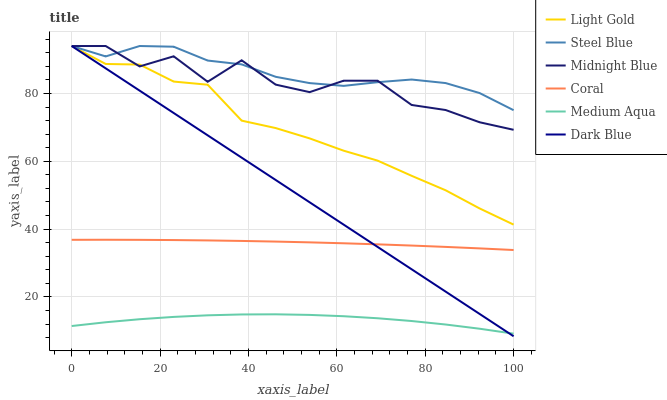Does Medium Aqua have the minimum area under the curve?
Answer yes or no. Yes. Does Steel Blue have the maximum area under the curve?
Answer yes or no. Yes. Does Coral have the minimum area under the curve?
Answer yes or no. No. Does Coral have the maximum area under the curve?
Answer yes or no. No. Is Dark Blue the smoothest?
Answer yes or no. Yes. Is Midnight Blue the roughest?
Answer yes or no. Yes. Is Coral the smoothest?
Answer yes or no. No. Is Coral the roughest?
Answer yes or no. No. Does Dark Blue have the lowest value?
Answer yes or no. Yes. Does Coral have the lowest value?
Answer yes or no. No. Does Light Gold have the highest value?
Answer yes or no. Yes. Does Coral have the highest value?
Answer yes or no. No. Is Medium Aqua less than Light Gold?
Answer yes or no. Yes. Is Midnight Blue greater than Medium Aqua?
Answer yes or no. Yes. Does Dark Blue intersect Medium Aqua?
Answer yes or no. Yes. Is Dark Blue less than Medium Aqua?
Answer yes or no. No. Is Dark Blue greater than Medium Aqua?
Answer yes or no. No. Does Medium Aqua intersect Light Gold?
Answer yes or no. No. 